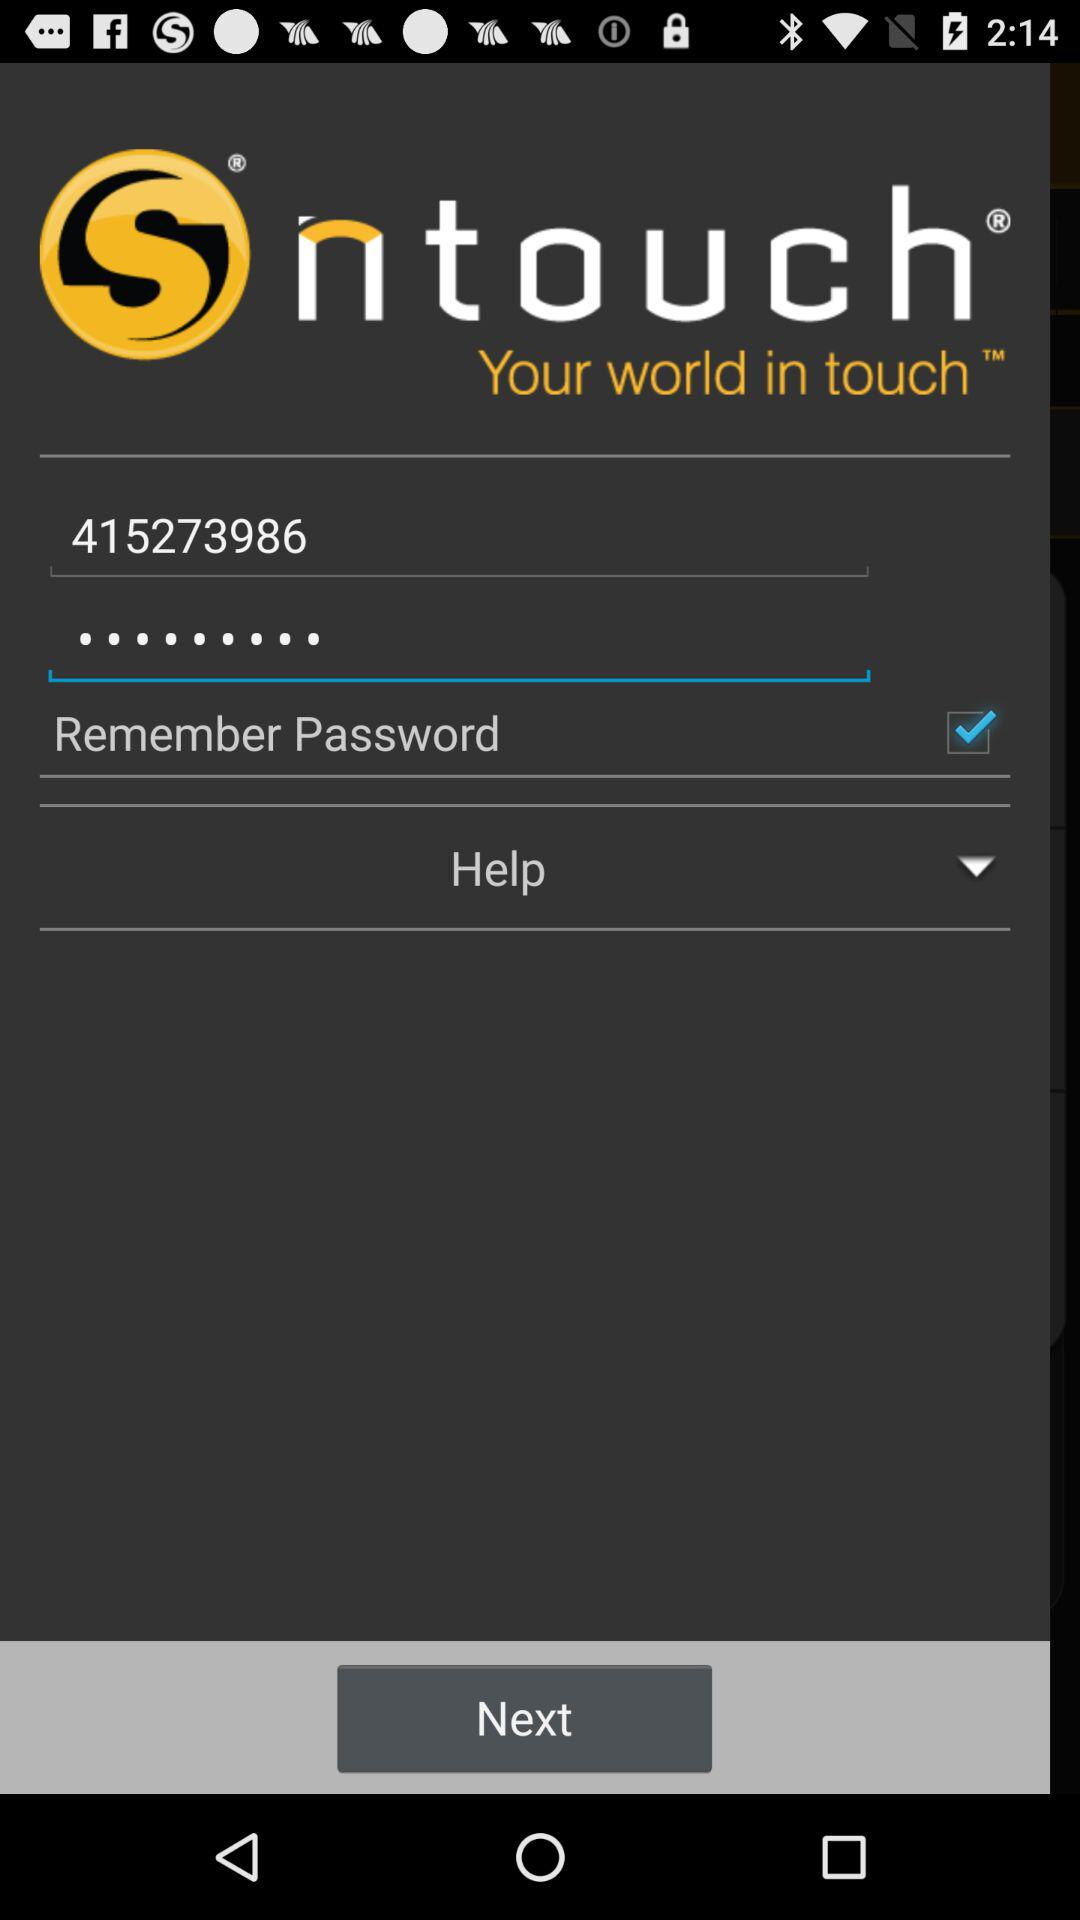What is the name of the application? The name of the application is "ntouch". 